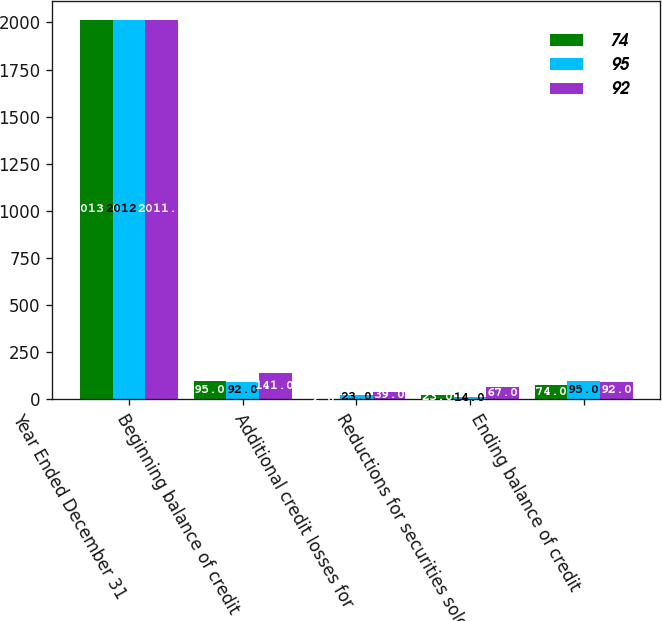Convert chart. <chart><loc_0><loc_0><loc_500><loc_500><stacked_bar_chart><ecel><fcel>Year Ended December 31<fcel>Beginning balance of credit<fcel>Additional credit losses for<fcel>Reductions for securities sold<fcel>Ending balance of credit<nl><fcel>74<fcel>2013<fcel>95<fcel>2<fcel>23<fcel>74<nl><fcel>95<fcel>2012<fcel>92<fcel>23<fcel>14<fcel>95<nl><fcel>92<fcel>2011<fcel>141<fcel>39<fcel>67<fcel>92<nl></chart> 